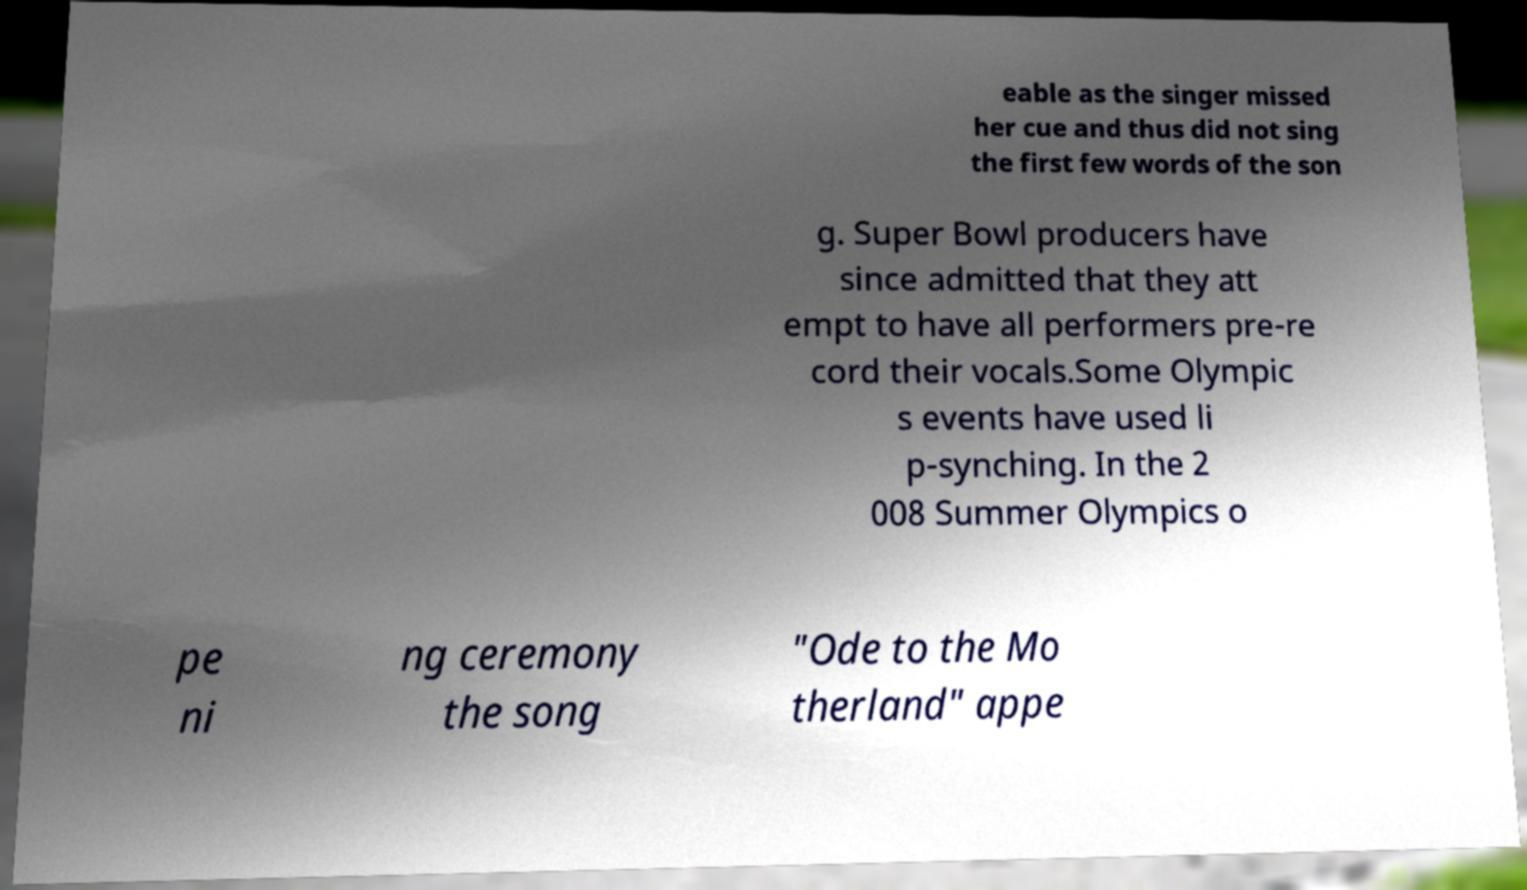What messages or text are displayed in this image? I need them in a readable, typed format. eable as the singer missed her cue and thus did not sing the first few words of the son g. Super Bowl producers have since admitted that they att empt to have all performers pre-re cord their vocals.Some Olympic s events have used li p-synching. In the 2 008 Summer Olympics o pe ni ng ceremony the song "Ode to the Mo therland" appe 